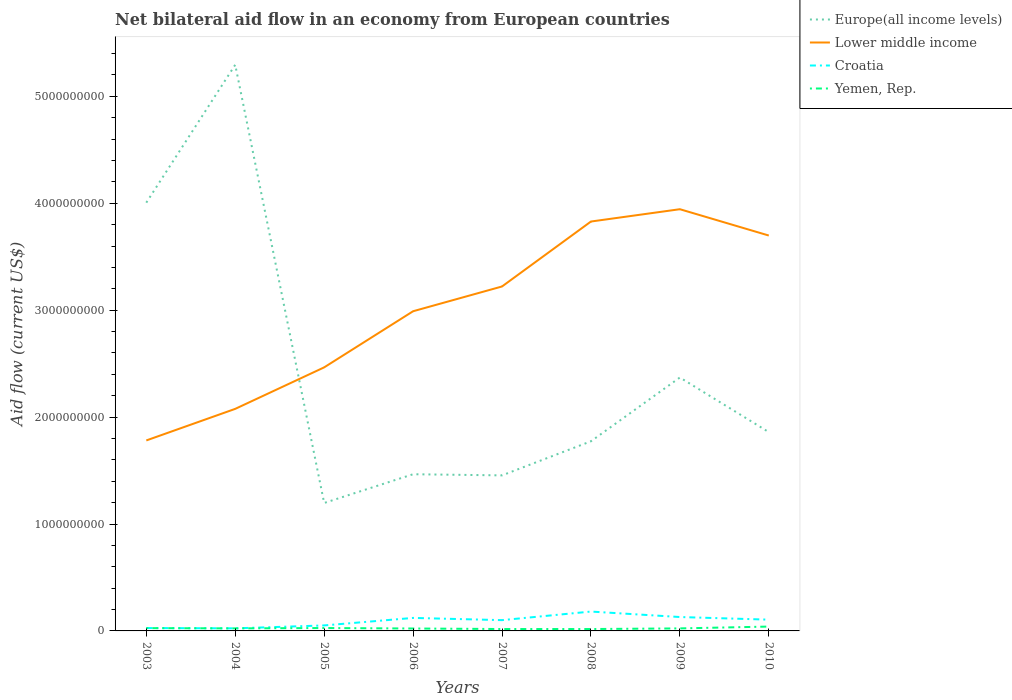Does the line corresponding to Yemen, Rep. intersect with the line corresponding to Croatia?
Your response must be concise. No. Is the number of lines equal to the number of legend labels?
Your response must be concise. Yes. Across all years, what is the maximum net bilateral aid flow in Europe(all income levels)?
Offer a terse response. 1.20e+09. What is the total net bilateral aid flow in Europe(all income levels) in the graph?
Your response must be concise. 3.84e+09. What is the difference between the highest and the second highest net bilateral aid flow in Lower middle income?
Your response must be concise. 2.16e+09. What is the difference between the highest and the lowest net bilateral aid flow in Lower middle income?
Your response must be concise. 4. Is the net bilateral aid flow in Croatia strictly greater than the net bilateral aid flow in Lower middle income over the years?
Ensure brevity in your answer.  Yes. How many lines are there?
Make the answer very short. 4. How many years are there in the graph?
Offer a very short reply. 8. Does the graph contain grids?
Keep it short and to the point. No. How many legend labels are there?
Provide a succinct answer. 4. What is the title of the graph?
Make the answer very short. Net bilateral aid flow in an economy from European countries. What is the label or title of the Y-axis?
Your response must be concise. Aid flow (current US$). What is the Aid flow (current US$) of Europe(all income levels) in 2003?
Your response must be concise. 4.01e+09. What is the Aid flow (current US$) of Lower middle income in 2003?
Provide a succinct answer. 1.78e+09. What is the Aid flow (current US$) in Croatia in 2003?
Your response must be concise. 2.69e+07. What is the Aid flow (current US$) of Yemen, Rep. in 2003?
Your answer should be very brief. 2.62e+07. What is the Aid flow (current US$) in Europe(all income levels) in 2004?
Provide a succinct answer. 5.29e+09. What is the Aid flow (current US$) of Lower middle income in 2004?
Make the answer very short. 2.08e+09. What is the Aid flow (current US$) of Croatia in 2004?
Make the answer very short. 2.41e+07. What is the Aid flow (current US$) of Yemen, Rep. in 2004?
Your answer should be very brief. 2.38e+07. What is the Aid flow (current US$) of Europe(all income levels) in 2005?
Give a very brief answer. 1.20e+09. What is the Aid flow (current US$) in Lower middle income in 2005?
Make the answer very short. 2.46e+09. What is the Aid flow (current US$) of Croatia in 2005?
Provide a succinct answer. 5.14e+07. What is the Aid flow (current US$) of Yemen, Rep. in 2005?
Offer a very short reply. 2.70e+07. What is the Aid flow (current US$) of Europe(all income levels) in 2006?
Provide a succinct answer. 1.47e+09. What is the Aid flow (current US$) of Lower middle income in 2006?
Make the answer very short. 2.99e+09. What is the Aid flow (current US$) of Croatia in 2006?
Ensure brevity in your answer.  1.22e+08. What is the Aid flow (current US$) in Yemen, Rep. in 2006?
Your answer should be very brief. 2.27e+07. What is the Aid flow (current US$) in Europe(all income levels) in 2007?
Ensure brevity in your answer.  1.45e+09. What is the Aid flow (current US$) in Lower middle income in 2007?
Ensure brevity in your answer.  3.22e+09. What is the Aid flow (current US$) in Croatia in 2007?
Your answer should be compact. 1.01e+08. What is the Aid flow (current US$) in Yemen, Rep. in 2007?
Offer a terse response. 1.77e+07. What is the Aid flow (current US$) in Europe(all income levels) in 2008?
Give a very brief answer. 1.77e+09. What is the Aid flow (current US$) in Lower middle income in 2008?
Your answer should be compact. 3.83e+09. What is the Aid flow (current US$) of Croatia in 2008?
Your response must be concise. 1.81e+08. What is the Aid flow (current US$) in Yemen, Rep. in 2008?
Keep it short and to the point. 1.77e+07. What is the Aid flow (current US$) of Europe(all income levels) in 2009?
Keep it short and to the point. 2.37e+09. What is the Aid flow (current US$) of Lower middle income in 2009?
Your answer should be very brief. 3.94e+09. What is the Aid flow (current US$) of Croatia in 2009?
Keep it short and to the point. 1.30e+08. What is the Aid flow (current US$) in Yemen, Rep. in 2009?
Ensure brevity in your answer.  2.36e+07. What is the Aid flow (current US$) in Europe(all income levels) in 2010?
Offer a very short reply. 1.86e+09. What is the Aid flow (current US$) in Lower middle income in 2010?
Your response must be concise. 3.70e+09. What is the Aid flow (current US$) of Croatia in 2010?
Offer a very short reply. 1.05e+08. What is the Aid flow (current US$) of Yemen, Rep. in 2010?
Offer a very short reply. 4.07e+07. Across all years, what is the maximum Aid flow (current US$) of Europe(all income levels)?
Your response must be concise. 5.29e+09. Across all years, what is the maximum Aid flow (current US$) of Lower middle income?
Give a very brief answer. 3.94e+09. Across all years, what is the maximum Aid flow (current US$) in Croatia?
Provide a succinct answer. 1.81e+08. Across all years, what is the maximum Aid flow (current US$) of Yemen, Rep.?
Keep it short and to the point. 4.07e+07. Across all years, what is the minimum Aid flow (current US$) in Europe(all income levels)?
Keep it short and to the point. 1.20e+09. Across all years, what is the minimum Aid flow (current US$) of Lower middle income?
Your answer should be compact. 1.78e+09. Across all years, what is the minimum Aid flow (current US$) of Croatia?
Offer a terse response. 2.41e+07. Across all years, what is the minimum Aid flow (current US$) of Yemen, Rep.?
Your response must be concise. 1.77e+07. What is the total Aid flow (current US$) of Europe(all income levels) in the graph?
Offer a terse response. 1.94e+1. What is the total Aid flow (current US$) in Lower middle income in the graph?
Your answer should be very brief. 2.40e+1. What is the total Aid flow (current US$) in Croatia in the graph?
Your answer should be very brief. 7.41e+08. What is the total Aid flow (current US$) in Yemen, Rep. in the graph?
Provide a short and direct response. 1.99e+08. What is the difference between the Aid flow (current US$) of Europe(all income levels) in 2003 and that in 2004?
Keep it short and to the point. -1.29e+09. What is the difference between the Aid flow (current US$) in Lower middle income in 2003 and that in 2004?
Keep it short and to the point. -2.95e+08. What is the difference between the Aid flow (current US$) of Croatia in 2003 and that in 2004?
Ensure brevity in your answer.  2.78e+06. What is the difference between the Aid flow (current US$) in Yemen, Rep. in 2003 and that in 2004?
Keep it short and to the point. 2.45e+06. What is the difference between the Aid flow (current US$) of Europe(all income levels) in 2003 and that in 2005?
Provide a succinct answer. 2.81e+09. What is the difference between the Aid flow (current US$) in Lower middle income in 2003 and that in 2005?
Offer a terse response. -6.83e+08. What is the difference between the Aid flow (current US$) in Croatia in 2003 and that in 2005?
Ensure brevity in your answer.  -2.45e+07. What is the difference between the Aid flow (current US$) of Yemen, Rep. in 2003 and that in 2005?
Your answer should be very brief. -8.50e+05. What is the difference between the Aid flow (current US$) in Europe(all income levels) in 2003 and that in 2006?
Provide a succinct answer. 2.54e+09. What is the difference between the Aid flow (current US$) in Lower middle income in 2003 and that in 2006?
Your answer should be very brief. -1.21e+09. What is the difference between the Aid flow (current US$) in Croatia in 2003 and that in 2006?
Provide a succinct answer. -9.48e+07. What is the difference between the Aid flow (current US$) in Yemen, Rep. in 2003 and that in 2006?
Ensure brevity in your answer.  3.49e+06. What is the difference between the Aid flow (current US$) of Europe(all income levels) in 2003 and that in 2007?
Offer a terse response. 2.55e+09. What is the difference between the Aid flow (current US$) in Lower middle income in 2003 and that in 2007?
Provide a short and direct response. -1.44e+09. What is the difference between the Aid flow (current US$) in Croatia in 2003 and that in 2007?
Offer a terse response. -7.40e+07. What is the difference between the Aid flow (current US$) in Yemen, Rep. in 2003 and that in 2007?
Provide a short and direct response. 8.46e+06. What is the difference between the Aid flow (current US$) in Europe(all income levels) in 2003 and that in 2008?
Your answer should be very brief. 2.23e+09. What is the difference between the Aid flow (current US$) in Lower middle income in 2003 and that in 2008?
Your answer should be compact. -2.05e+09. What is the difference between the Aid flow (current US$) in Croatia in 2003 and that in 2008?
Keep it short and to the point. -1.54e+08. What is the difference between the Aid flow (current US$) of Yemen, Rep. in 2003 and that in 2008?
Make the answer very short. 8.50e+06. What is the difference between the Aid flow (current US$) of Europe(all income levels) in 2003 and that in 2009?
Your answer should be compact. 1.64e+09. What is the difference between the Aid flow (current US$) in Lower middle income in 2003 and that in 2009?
Offer a terse response. -2.16e+09. What is the difference between the Aid flow (current US$) in Croatia in 2003 and that in 2009?
Your response must be concise. -1.03e+08. What is the difference between the Aid flow (current US$) in Yemen, Rep. in 2003 and that in 2009?
Offer a very short reply. 2.60e+06. What is the difference between the Aid flow (current US$) of Europe(all income levels) in 2003 and that in 2010?
Your response must be concise. 2.15e+09. What is the difference between the Aid flow (current US$) in Lower middle income in 2003 and that in 2010?
Offer a very short reply. -1.92e+09. What is the difference between the Aid flow (current US$) in Croatia in 2003 and that in 2010?
Give a very brief answer. -7.85e+07. What is the difference between the Aid flow (current US$) of Yemen, Rep. in 2003 and that in 2010?
Your answer should be very brief. -1.45e+07. What is the difference between the Aid flow (current US$) in Europe(all income levels) in 2004 and that in 2005?
Provide a short and direct response. 4.10e+09. What is the difference between the Aid flow (current US$) of Lower middle income in 2004 and that in 2005?
Ensure brevity in your answer.  -3.88e+08. What is the difference between the Aid flow (current US$) of Croatia in 2004 and that in 2005?
Give a very brief answer. -2.73e+07. What is the difference between the Aid flow (current US$) in Yemen, Rep. in 2004 and that in 2005?
Offer a terse response. -3.30e+06. What is the difference between the Aid flow (current US$) of Europe(all income levels) in 2004 and that in 2006?
Provide a succinct answer. 3.83e+09. What is the difference between the Aid flow (current US$) of Lower middle income in 2004 and that in 2006?
Your answer should be very brief. -9.13e+08. What is the difference between the Aid flow (current US$) in Croatia in 2004 and that in 2006?
Offer a very short reply. -9.76e+07. What is the difference between the Aid flow (current US$) of Yemen, Rep. in 2004 and that in 2006?
Your answer should be very brief. 1.04e+06. What is the difference between the Aid flow (current US$) of Europe(all income levels) in 2004 and that in 2007?
Offer a terse response. 3.84e+09. What is the difference between the Aid flow (current US$) in Lower middle income in 2004 and that in 2007?
Offer a terse response. -1.14e+09. What is the difference between the Aid flow (current US$) in Croatia in 2004 and that in 2007?
Ensure brevity in your answer.  -7.68e+07. What is the difference between the Aid flow (current US$) in Yemen, Rep. in 2004 and that in 2007?
Offer a terse response. 6.01e+06. What is the difference between the Aid flow (current US$) of Europe(all income levels) in 2004 and that in 2008?
Ensure brevity in your answer.  3.52e+09. What is the difference between the Aid flow (current US$) in Lower middle income in 2004 and that in 2008?
Provide a short and direct response. -1.75e+09. What is the difference between the Aid flow (current US$) of Croatia in 2004 and that in 2008?
Your answer should be very brief. -1.57e+08. What is the difference between the Aid flow (current US$) in Yemen, Rep. in 2004 and that in 2008?
Your answer should be compact. 6.05e+06. What is the difference between the Aid flow (current US$) of Europe(all income levels) in 2004 and that in 2009?
Your answer should be very brief. 2.92e+09. What is the difference between the Aid flow (current US$) in Lower middle income in 2004 and that in 2009?
Ensure brevity in your answer.  -1.87e+09. What is the difference between the Aid flow (current US$) of Croatia in 2004 and that in 2009?
Your response must be concise. -1.06e+08. What is the difference between the Aid flow (current US$) of Yemen, Rep. in 2004 and that in 2009?
Give a very brief answer. 1.50e+05. What is the difference between the Aid flow (current US$) of Europe(all income levels) in 2004 and that in 2010?
Offer a terse response. 3.44e+09. What is the difference between the Aid flow (current US$) in Lower middle income in 2004 and that in 2010?
Your answer should be very brief. -1.62e+09. What is the difference between the Aid flow (current US$) in Croatia in 2004 and that in 2010?
Provide a succinct answer. -8.13e+07. What is the difference between the Aid flow (current US$) of Yemen, Rep. in 2004 and that in 2010?
Offer a terse response. -1.70e+07. What is the difference between the Aid flow (current US$) of Europe(all income levels) in 2005 and that in 2006?
Your answer should be very brief. -2.69e+08. What is the difference between the Aid flow (current US$) of Lower middle income in 2005 and that in 2006?
Your answer should be compact. -5.25e+08. What is the difference between the Aid flow (current US$) in Croatia in 2005 and that in 2006?
Your answer should be compact. -7.03e+07. What is the difference between the Aid flow (current US$) of Yemen, Rep. in 2005 and that in 2006?
Give a very brief answer. 4.34e+06. What is the difference between the Aid flow (current US$) of Europe(all income levels) in 2005 and that in 2007?
Provide a succinct answer. -2.58e+08. What is the difference between the Aid flow (current US$) of Lower middle income in 2005 and that in 2007?
Offer a terse response. -7.57e+08. What is the difference between the Aid flow (current US$) in Croatia in 2005 and that in 2007?
Your answer should be compact. -4.95e+07. What is the difference between the Aid flow (current US$) of Yemen, Rep. in 2005 and that in 2007?
Your answer should be compact. 9.31e+06. What is the difference between the Aid flow (current US$) in Europe(all income levels) in 2005 and that in 2008?
Your answer should be compact. -5.77e+08. What is the difference between the Aid flow (current US$) of Lower middle income in 2005 and that in 2008?
Make the answer very short. -1.36e+09. What is the difference between the Aid flow (current US$) of Croatia in 2005 and that in 2008?
Offer a terse response. -1.30e+08. What is the difference between the Aid flow (current US$) of Yemen, Rep. in 2005 and that in 2008?
Your answer should be very brief. 9.35e+06. What is the difference between the Aid flow (current US$) in Europe(all income levels) in 2005 and that in 2009?
Your answer should be very brief. -1.17e+09. What is the difference between the Aid flow (current US$) in Lower middle income in 2005 and that in 2009?
Keep it short and to the point. -1.48e+09. What is the difference between the Aid flow (current US$) in Croatia in 2005 and that in 2009?
Offer a terse response. -7.85e+07. What is the difference between the Aid flow (current US$) of Yemen, Rep. in 2005 and that in 2009?
Provide a short and direct response. 3.45e+06. What is the difference between the Aid flow (current US$) of Europe(all income levels) in 2005 and that in 2010?
Your response must be concise. -6.63e+08. What is the difference between the Aid flow (current US$) in Lower middle income in 2005 and that in 2010?
Your answer should be very brief. -1.23e+09. What is the difference between the Aid flow (current US$) in Croatia in 2005 and that in 2010?
Provide a succinct answer. -5.40e+07. What is the difference between the Aid flow (current US$) of Yemen, Rep. in 2005 and that in 2010?
Keep it short and to the point. -1.37e+07. What is the difference between the Aid flow (current US$) of Europe(all income levels) in 2006 and that in 2007?
Give a very brief answer. 1.07e+07. What is the difference between the Aid flow (current US$) in Lower middle income in 2006 and that in 2007?
Make the answer very short. -2.32e+08. What is the difference between the Aid flow (current US$) in Croatia in 2006 and that in 2007?
Your response must be concise. 2.08e+07. What is the difference between the Aid flow (current US$) of Yemen, Rep. in 2006 and that in 2007?
Keep it short and to the point. 4.97e+06. What is the difference between the Aid flow (current US$) of Europe(all income levels) in 2006 and that in 2008?
Your response must be concise. -3.08e+08. What is the difference between the Aid flow (current US$) in Lower middle income in 2006 and that in 2008?
Keep it short and to the point. -8.39e+08. What is the difference between the Aid flow (current US$) of Croatia in 2006 and that in 2008?
Provide a succinct answer. -5.94e+07. What is the difference between the Aid flow (current US$) in Yemen, Rep. in 2006 and that in 2008?
Ensure brevity in your answer.  5.01e+06. What is the difference between the Aid flow (current US$) in Europe(all income levels) in 2006 and that in 2009?
Offer a terse response. -9.05e+08. What is the difference between the Aid flow (current US$) in Lower middle income in 2006 and that in 2009?
Ensure brevity in your answer.  -9.54e+08. What is the difference between the Aid flow (current US$) in Croatia in 2006 and that in 2009?
Your answer should be compact. -8.24e+06. What is the difference between the Aid flow (current US$) of Yemen, Rep. in 2006 and that in 2009?
Your answer should be compact. -8.90e+05. What is the difference between the Aid flow (current US$) in Europe(all income levels) in 2006 and that in 2010?
Provide a short and direct response. -3.94e+08. What is the difference between the Aid flow (current US$) in Lower middle income in 2006 and that in 2010?
Your response must be concise. -7.08e+08. What is the difference between the Aid flow (current US$) in Croatia in 2006 and that in 2010?
Offer a very short reply. 1.63e+07. What is the difference between the Aid flow (current US$) in Yemen, Rep. in 2006 and that in 2010?
Give a very brief answer. -1.80e+07. What is the difference between the Aid flow (current US$) in Europe(all income levels) in 2007 and that in 2008?
Ensure brevity in your answer.  -3.19e+08. What is the difference between the Aid flow (current US$) in Lower middle income in 2007 and that in 2008?
Make the answer very short. -6.07e+08. What is the difference between the Aid flow (current US$) in Croatia in 2007 and that in 2008?
Keep it short and to the point. -8.03e+07. What is the difference between the Aid flow (current US$) of Europe(all income levels) in 2007 and that in 2009?
Offer a very short reply. -9.15e+08. What is the difference between the Aid flow (current US$) in Lower middle income in 2007 and that in 2009?
Your answer should be compact. -7.23e+08. What is the difference between the Aid flow (current US$) in Croatia in 2007 and that in 2009?
Your answer should be compact. -2.91e+07. What is the difference between the Aid flow (current US$) in Yemen, Rep. in 2007 and that in 2009?
Offer a very short reply. -5.86e+06. What is the difference between the Aid flow (current US$) of Europe(all income levels) in 2007 and that in 2010?
Provide a short and direct response. -4.05e+08. What is the difference between the Aid flow (current US$) in Lower middle income in 2007 and that in 2010?
Keep it short and to the point. -4.76e+08. What is the difference between the Aid flow (current US$) in Croatia in 2007 and that in 2010?
Your answer should be compact. -4.52e+06. What is the difference between the Aid flow (current US$) of Yemen, Rep. in 2007 and that in 2010?
Your answer should be very brief. -2.30e+07. What is the difference between the Aid flow (current US$) in Europe(all income levels) in 2008 and that in 2009?
Provide a succinct answer. -5.96e+08. What is the difference between the Aid flow (current US$) in Lower middle income in 2008 and that in 2009?
Offer a terse response. -1.15e+08. What is the difference between the Aid flow (current US$) in Croatia in 2008 and that in 2009?
Make the answer very short. 5.12e+07. What is the difference between the Aid flow (current US$) of Yemen, Rep. in 2008 and that in 2009?
Offer a very short reply. -5.90e+06. What is the difference between the Aid flow (current US$) of Europe(all income levels) in 2008 and that in 2010?
Keep it short and to the point. -8.57e+07. What is the difference between the Aid flow (current US$) of Lower middle income in 2008 and that in 2010?
Your response must be concise. 1.31e+08. What is the difference between the Aid flow (current US$) in Croatia in 2008 and that in 2010?
Give a very brief answer. 7.57e+07. What is the difference between the Aid flow (current US$) of Yemen, Rep. in 2008 and that in 2010?
Your answer should be compact. -2.30e+07. What is the difference between the Aid flow (current US$) of Europe(all income levels) in 2009 and that in 2010?
Provide a short and direct response. 5.11e+08. What is the difference between the Aid flow (current US$) in Lower middle income in 2009 and that in 2010?
Ensure brevity in your answer.  2.46e+08. What is the difference between the Aid flow (current US$) of Croatia in 2009 and that in 2010?
Provide a succinct answer. 2.46e+07. What is the difference between the Aid flow (current US$) in Yemen, Rep. in 2009 and that in 2010?
Provide a short and direct response. -1.71e+07. What is the difference between the Aid flow (current US$) of Europe(all income levels) in 2003 and the Aid flow (current US$) of Lower middle income in 2004?
Your answer should be very brief. 1.93e+09. What is the difference between the Aid flow (current US$) in Europe(all income levels) in 2003 and the Aid flow (current US$) in Croatia in 2004?
Your answer should be compact. 3.98e+09. What is the difference between the Aid flow (current US$) of Europe(all income levels) in 2003 and the Aid flow (current US$) of Yemen, Rep. in 2004?
Offer a terse response. 3.98e+09. What is the difference between the Aid flow (current US$) of Lower middle income in 2003 and the Aid flow (current US$) of Croatia in 2004?
Make the answer very short. 1.76e+09. What is the difference between the Aid flow (current US$) in Lower middle income in 2003 and the Aid flow (current US$) in Yemen, Rep. in 2004?
Give a very brief answer. 1.76e+09. What is the difference between the Aid flow (current US$) of Croatia in 2003 and the Aid flow (current US$) of Yemen, Rep. in 2004?
Make the answer very short. 3.14e+06. What is the difference between the Aid flow (current US$) in Europe(all income levels) in 2003 and the Aid flow (current US$) in Lower middle income in 2005?
Provide a succinct answer. 1.54e+09. What is the difference between the Aid flow (current US$) in Europe(all income levels) in 2003 and the Aid flow (current US$) in Croatia in 2005?
Provide a succinct answer. 3.95e+09. What is the difference between the Aid flow (current US$) of Europe(all income levels) in 2003 and the Aid flow (current US$) of Yemen, Rep. in 2005?
Offer a very short reply. 3.98e+09. What is the difference between the Aid flow (current US$) of Lower middle income in 2003 and the Aid flow (current US$) of Croatia in 2005?
Offer a very short reply. 1.73e+09. What is the difference between the Aid flow (current US$) of Lower middle income in 2003 and the Aid flow (current US$) of Yemen, Rep. in 2005?
Your answer should be compact. 1.75e+09. What is the difference between the Aid flow (current US$) of Europe(all income levels) in 2003 and the Aid flow (current US$) of Lower middle income in 2006?
Provide a short and direct response. 1.02e+09. What is the difference between the Aid flow (current US$) in Europe(all income levels) in 2003 and the Aid flow (current US$) in Croatia in 2006?
Ensure brevity in your answer.  3.88e+09. What is the difference between the Aid flow (current US$) of Europe(all income levels) in 2003 and the Aid flow (current US$) of Yemen, Rep. in 2006?
Give a very brief answer. 3.98e+09. What is the difference between the Aid flow (current US$) in Lower middle income in 2003 and the Aid flow (current US$) in Croatia in 2006?
Provide a succinct answer. 1.66e+09. What is the difference between the Aid flow (current US$) in Lower middle income in 2003 and the Aid flow (current US$) in Yemen, Rep. in 2006?
Offer a terse response. 1.76e+09. What is the difference between the Aid flow (current US$) of Croatia in 2003 and the Aid flow (current US$) of Yemen, Rep. in 2006?
Make the answer very short. 4.18e+06. What is the difference between the Aid flow (current US$) of Europe(all income levels) in 2003 and the Aid flow (current US$) of Lower middle income in 2007?
Your answer should be very brief. 7.84e+08. What is the difference between the Aid flow (current US$) in Europe(all income levels) in 2003 and the Aid flow (current US$) in Croatia in 2007?
Your answer should be very brief. 3.90e+09. What is the difference between the Aid flow (current US$) in Europe(all income levels) in 2003 and the Aid flow (current US$) in Yemen, Rep. in 2007?
Keep it short and to the point. 3.99e+09. What is the difference between the Aid flow (current US$) in Lower middle income in 2003 and the Aid flow (current US$) in Croatia in 2007?
Offer a very short reply. 1.68e+09. What is the difference between the Aid flow (current US$) of Lower middle income in 2003 and the Aid flow (current US$) of Yemen, Rep. in 2007?
Provide a short and direct response. 1.76e+09. What is the difference between the Aid flow (current US$) of Croatia in 2003 and the Aid flow (current US$) of Yemen, Rep. in 2007?
Provide a succinct answer. 9.15e+06. What is the difference between the Aid flow (current US$) of Europe(all income levels) in 2003 and the Aid flow (current US$) of Lower middle income in 2008?
Your response must be concise. 1.76e+08. What is the difference between the Aid flow (current US$) in Europe(all income levels) in 2003 and the Aid flow (current US$) in Croatia in 2008?
Your response must be concise. 3.82e+09. What is the difference between the Aid flow (current US$) in Europe(all income levels) in 2003 and the Aid flow (current US$) in Yemen, Rep. in 2008?
Your answer should be very brief. 3.99e+09. What is the difference between the Aid flow (current US$) of Lower middle income in 2003 and the Aid flow (current US$) of Croatia in 2008?
Your response must be concise. 1.60e+09. What is the difference between the Aid flow (current US$) in Lower middle income in 2003 and the Aid flow (current US$) in Yemen, Rep. in 2008?
Give a very brief answer. 1.76e+09. What is the difference between the Aid flow (current US$) of Croatia in 2003 and the Aid flow (current US$) of Yemen, Rep. in 2008?
Your answer should be compact. 9.19e+06. What is the difference between the Aid flow (current US$) of Europe(all income levels) in 2003 and the Aid flow (current US$) of Lower middle income in 2009?
Your answer should be very brief. 6.12e+07. What is the difference between the Aid flow (current US$) in Europe(all income levels) in 2003 and the Aid flow (current US$) in Croatia in 2009?
Keep it short and to the point. 3.88e+09. What is the difference between the Aid flow (current US$) in Europe(all income levels) in 2003 and the Aid flow (current US$) in Yemen, Rep. in 2009?
Ensure brevity in your answer.  3.98e+09. What is the difference between the Aid flow (current US$) in Lower middle income in 2003 and the Aid flow (current US$) in Croatia in 2009?
Ensure brevity in your answer.  1.65e+09. What is the difference between the Aid flow (current US$) in Lower middle income in 2003 and the Aid flow (current US$) in Yemen, Rep. in 2009?
Make the answer very short. 1.76e+09. What is the difference between the Aid flow (current US$) in Croatia in 2003 and the Aid flow (current US$) in Yemen, Rep. in 2009?
Make the answer very short. 3.29e+06. What is the difference between the Aid flow (current US$) of Europe(all income levels) in 2003 and the Aid flow (current US$) of Lower middle income in 2010?
Provide a succinct answer. 3.07e+08. What is the difference between the Aid flow (current US$) in Europe(all income levels) in 2003 and the Aid flow (current US$) in Croatia in 2010?
Your answer should be very brief. 3.90e+09. What is the difference between the Aid flow (current US$) of Europe(all income levels) in 2003 and the Aid flow (current US$) of Yemen, Rep. in 2010?
Keep it short and to the point. 3.96e+09. What is the difference between the Aid flow (current US$) of Lower middle income in 2003 and the Aid flow (current US$) of Croatia in 2010?
Your answer should be compact. 1.68e+09. What is the difference between the Aid flow (current US$) in Lower middle income in 2003 and the Aid flow (current US$) in Yemen, Rep. in 2010?
Give a very brief answer. 1.74e+09. What is the difference between the Aid flow (current US$) in Croatia in 2003 and the Aid flow (current US$) in Yemen, Rep. in 2010?
Offer a very short reply. -1.38e+07. What is the difference between the Aid flow (current US$) in Europe(all income levels) in 2004 and the Aid flow (current US$) in Lower middle income in 2005?
Give a very brief answer. 2.83e+09. What is the difference between the Aid flow (current US$) in Europe(all income levels) in 2004 and the Aid flow (current US$) in Croatia in 2005?
Keep it short and to the point. 5.24e+09. What is the difference between the Aid flow (current US$) of Europe(all income levels) in 2004 and the Aid flow (current US$) of Yemen, Rep. in 2005?
Your response must be concise. 5.27e+09. What is the difference between the Aid flow (current US$) in Lower middle income in 2004 and the Aid flow (current US$) in Croatia in 2005?
Provide a short and direct response. 2.03e+09. What is the difference between the Aid flow (current US$) in Lower middle income in 2004 and the Aid flow (current US$) in Yemen, Rep. in 2005?
Keep it short and to the point. 2.05e+09. What is the difference between the Aid flow (current US$) in Croatia in 2004 and the Aid flow (current US$) in Yemen, Rep. in 2005?
Your answer should be compact. -2.94e+06. What is the difference between the Aid flow (current US$) in Europe(all income levels) in 2004 and the Aid flow (current US$) in Lower middle income in 2006?
Your answer should be very brief. 2.31e+09. What is the difference between the Aid flow (current US$) of Europe(all income levels) in 2004 and the Aid flow (current US$) of Croatia in 2006?
Offer a very short reply. 5.17e+09. What is the difference between the Aid flow (current US$) of Europe(all income levels) in 2004 and the Aid flow (current US$) of Yemen, Rep. in 2006?
Keep it short and to the point. 5.27e+09. What is the difference between the Aid flow (current US$) in Lower middle income in 2004 and the Aid flow (current US$) in Croatia in 2006?
Make the answer very short. 1.96e+09. What is the difference between the Aid flow (current US$) of Lower middle income in 2004 and the Aid flow (current US$) of Yemen, Rep. in 2006?
Your response must be concise. 2.05e+09. What is the difference between the Aid flow (current US$) of Croatia in 2004 and the Aid flow (current US$) of Yemen, Rep. in 2006?
Ensure brevity in your answer.  1.40e+06. What is the difference between the Aid flow (current US$) in Europe(all income levels) in 2004 and the Aid flow (current US$) in Lower middle income in 2007?
Your answer should be very brief. 2.07e+09. What is the difference between the Aid flow (current US$) in Europe(all income levels) in 2004 and the Aid flow (current US$) in Croatia in 2007?
Offer a terse response. 5.19e+09. What is the difference between the Aid flow (current US$) in Europe(all income levels) in 2004 and the Aid flow (current US$) in Yemen, Rep. in 2007?
Offer a very short reply. 5.28e+09. What is the difference between the Aid flow (current US$) of Lower middle income in 2004 and the Aid flow (current US$) of Croatia in 2007?
Your answer should be very brief. 1.98e+09. What is the difference between the Aid flow (current US$) of Lower middle income in 2004 and the Aid flow (current US$) of Yemen, Rep. in 2007?
Your response must be concise. 2.06e+09. What is the difference between the Aid flow (current US$) in Croatia in 2004 and the Aid flow (current US$) in Yemen, Rep. in 2007?
Provide a short and direct response. 6.37e+06. What is the difference between the Aid flow (current US$) in Europe(all income levels) in 2004 and the Aid flow (current US$) in Lower middle income in 2008?
Offer a terse response. 1.47e+09. What is the difference between the Aid flow (current US$) of Europe(all income levels) in 2004 and the Aid flow (current US$) of Croatia in 2008?
Give a very brief answer. 5.11e+09. What is the difference between the Aid flow (current US$) of Europe(all income levels) in 2004 and the Aid flow (current US$) of Yemen, Rep. in 2008?
Your answer should be compact. 5.28e+09. What is the difference between the Aid flow (current US$) in Lower middle income in 2004 and the Aid flow (current US$) in Croatia in 2008?
Ensure brevity in your answer.  1.90e+09. What is the difference between the Aid flow (current US$) of Lower middle income in 2004 and the Aid flow (current US$) of Yemen, Rep. in 2008?
Offer a terse response. 2.06e+09. What is the difference between the Aid flow (current US$) in Croatia in 2004 and the Aid flow (current US$) in Yemen, Rep. in 2008?
Your answer should be compact. 6.41e+06. What is the difference between the Aid flow (current US$) of Europe(all income levels) in 2004 and the Aid flow (current US$) of Lower middle income in 2009?
Your answer should be very brief. 1.35e+09. What is the difference between the Aid flow (current US$) of Europe(all income levels) in 2004 and the Aid flow (current US$) of Croatia in 2009?
Provide a short and direct response. 5.17e+09. What is the difference between the Aid flow (current US$) of Europe(all income levels) in 2004 and the Aid flow (current US$) of Yemen, Rep. in 2009?
Your answer should be very brief. 5.27e+09. What is the difference between the Aid flow (current US$) of Lower middle income in 2004 and the Aid flow (current US$) of Croatia in 2009?
Your response must be concise. 1.95e+09. What is the difference between the Aid flow (current US$) of Lower middle income in 2004 and the Aid flow (current US$) of Yemen, Rep. in 2009?
Offer a very short reply. 2.05e+09. What is the difference between the Aid flow (current US$) of Croatia in 2004 and the Aid flow (current US$) of Yemen, Rep. in 2009?
Your response must be concise. 5.10e+05. What is the difference between the Aid flow (current US$) in Europe(all income levels) in 2004 and the Aid flow (current US$) in Lower middle income in 2010?
Provide a short and direct response. 1.60e+09. What is the difference between the Aid flow (current US$) in Europe(all income levels) in 2004 and the Aid flow (current US$) in Croatia in 2010?
Give a very brief answer. 5.19e+09. What is the difference between the Aid flow (current US$) in Europe(all income levels) in 2004 and the Aid flow (current US$) in Yemen, Rep. in 2010?
Your answer should be very brief. 5.25e+09. What is the difference between the Aid flow (current US$) in Lower middle income in 2004 and the Aid flow (current US$) in Croatia in 2010?
Keep it short and to the point. 1.97e+09. What is the difference between the Aid flow (current US$) of Lower middle income in 2004 and the Aid flow (current US$) of Yemen, Rep. in 2010?
Give a very brief answer. 2.04e+09. What is the difference between the Aid flow (current US$) of Croatia in 2004 and the Aid flow (current US$) of Yemen, Rep. in 2010?
Offer a very short reply. -1.66e+07. What is the difference between the Aid flow (current US$) of Europe(all income levels) in 2005 and the Aid flow (current US$) of Lower middle income in 2006?
Your answer should be very brief. -1.79e+09. What is the difference between the Aid flow (current US$) of Europe(all income levels) in 2005 and the Aid flow (current US$) of Croatia in 2006?
Ensure brevity in your answer.  1.07e+09. What is the difference between the Aid flow (current US$) in Europe(all income levels) in 2005 and the Aid flow (current US$) in Yemen, Rep. in 2006?
Your response must be concise. 1.17e+09. What is the difference between the Aid flow (current US$) of Lower middle income in 2005 and the Aid flow (current US$) of Croatia in 2006?
Your answer should be very brief. 2.34e+09. What is the difference between the Aid flow (current US$) in Lower middle income in 2005 and the Aid flow (current US$) in Yemen, Rep. in 2006?
Make the answer very short. 2.44e+09. What is the difference between the Aid flow (current US$) of Croatia in 2005 and the Aid flow (current US$) of Yemen, Rep. in 2006?
Your response must be concise. 2.87e+07. What is the difference between the Aid flow (current US$) in Europe(all income levels) in 2005 and the Aid flow (current US$) in Lower middle income in 2007?
Keep it short and to the point. -2.02e+09. What is the difference between the Aid flow (current US$) in Europe(all income levels) in 2005 and the Aid flow (current US$) in Croatia in 2007?
Your answer should be compact. 1.10e+09. What is the difference between the Aid flow (current US$) in Europe(all income levels) in 2005 and the Aid flow (current US$) in Yemen, Rep. in 2007?
Your answer should be compact. 1.18e+09. What is the difference between the Aid flow (current US$) of Lower middle income in 2005 and the Aid flow (current US$) of Croatia in 2007?
Your response must be concise. 2.36e+09. What is the difference between the Aid flow (current US$) in Lower middle income in 2005 and the Aid flow (current US$) in Yemen, Rep. in 2007?
Keep it short and to the point. 2.45e+09. What is the difference between the Aid flow (current US$) in Croatia in 2005 and the Aid flow (current US$) in Yemen, Rep. in 2007?
Keep it short and to the point. 3.37e+07. What is the difference between the Aid flow (current US$) of Europe(all income levels) in 2005 and the Aid flow (current US$) of Lower middle income in 2008?
Ensure brevity in your answer.  -2.63e+09. What is the difference between the Aid flow (current US$) of Europe(all income levels) in 2005 and the Aid flow (current US$) of Croatia in 2008?
Provide a short and direct response. 1.02e+09. What is the difference between the Aid flow (current US$) in Europe(all income levels) in 2005 and the Aid flow (current US$) in Yemen, Rep. in 2008?
Your answer should be very brief. 1.18e+09. What is the difference between the Aid flow (current US$) of Lower middle income in 2005 and the Aid flow (current US$) of Croatia in 2008?
Provide a short and direct response. 2.28e+09. What is the difference between the Aid flow (current US$) of Lower middle income in 2005 and the Aid flow (current US$) of Yemen, Rep. in 2008?
Offer a terse response. 2.45e+09. What is the difference between the Aid flow (current US$) in Croatia in 2005 and the Aid flow (current US$) in Yemen, Rep. in 2008?
Your response must be concise. 3.37e+07. What is the difference between the Aid flow (current US$) in Europe(all income levels) in 2005 and the Aid flow (current US$) in Lower middle income in 2009?
Give a very brief answer. -2.75e+09. What is the difference between the Aid flow (current US$) in Europe(all income levels) in 2005 and the Aid flow (current US$) in Croatia in 2009?
Offer a very short reply. 1.07e+09. What is the difference between the Aid flow (current US$) in Europe(all income levels) in 2005 and the Aid flow (current US$) in Yemen, Rep. in 2009?
Give a very brief answer. 1.17e+09. What is the difference between the Aid flow (current US$) of Lower middle income in 2005 and the Aid flow (current US$) of Croatia in 2009?
Ensure brevity in your answer.  2.33e+09. What is the difference between the Aid flow (current US$) of Lower middle income in 2005 and the Aid flow (current US$) of Yemen, Rep. in 2009?
Your answer should be compact. 2.44e+09. What is the difference between the Aid flow (current US$) of Croatia in 2005 and the Aid flow (current US$) of Yemen, Rep. in 2009?
Your response must be concise. 2.78e+07. What is the difference between the Aid flow (current US$) in Europe(all income levels) in 2005 and the Aid flow (current US$) in Lower middle income in 2010?
Your answer should be very brief. -2.50e+09. What is the difference between the Aid flow (current US$) in Europe(all income levels) in 2005 and the Aid flow (current US$) in Croatia in 2010?
Provide a succinct answer. 1.09e+09. What is the difference between the Aid flow (current US$) in Europe(all income levels) in 2005 and the Aid flow (current US$) in Yemen, Rep. in 2010?
Provide a succinct answer. 1.16e+09. What is the difference between the Aid flow (current US$) in Lower middle income in 2005 and the Aid flow (current US$) in Croatia in 2010?
Your response must be concise. 2.36e+09. What is the difference between the Aid flow (current US$) of Lower middle income in 2005 and the Aid flow (current US$) of Yemen, Rep. in 2010?
Offer a terse response. 2.42e+09. What is the difference between the Aid flow (current US$) in Croatia in 2005 and the Aid flow (current US$) in Yemen, Rep. in 2010?
Provide a short and direct response. 1.07e+07. What is the difference between the Aid flow (current US$) of Europe(all income levels) in 2006 and the Aid flow (current US$) of Lower middle income in 2007?
Make the answer very short. -1.76e+09. What is the difference between the Aid flow (current US$) of Europe(all income levels) in 2006 and the Aid flow (current US$) of Croatia in 2007?
Your response must be concise. 1.36e+09. What is the difference between the Aid flow (current US$) of Europe(all income levels) in 2006 and the Aid flow (current US$) of Yemen, Rep. in 2007?
Offer a very short reply. 1.45e+09. What is the difference between the Aid flow (current US$) of Lower middle income in 2006 and the Aid flow (current US$) of Croatia in 2007?
Offer a very short reply. 2.89e+09. What is the difference between the Aid flow (current US$) of Lower middle income in 2006 and the Aid flow (current US$) of Yemen, Rep. in 2007?
Your answer should be compact. 2.97e+09. What is the difference between the Aid flow (current US$) of Croatia in 2006 and the Aid flow (current US$) of Yemen, Rep. in 2007?
Keep it short and to the point. 1.04e+08. What is the difference between the Aid flow (current US$) of Europe(all income levels) in 2006 and the Aid flow (current US$) of Lower middle income in 2008?
Provide a succinct answer. -2.36e+09. What is the difference between the Aid flow (current US$) in Europe(all income levels) in 2006 and the Aid flow (current US$) in Croatia in 2008?
Ensure brevity in your answer.  1.28e+09. What is the difference between the Aid flow (current US$) in Europe(all income levels) in 2006 and the Aid flow (current US$) in Yemen, Rep. in 2008?
Offer a terse response. 1.45e+09. What is the difference between the Aid flow (current US$) in Lower middle income in 2006 and the Aid flow (current US$) in Croatia in 2008?
Offer a terse response. 2.81e+09. What is the difference between the Aid flow (current US$) of Lower middle income in 2006 and the Aid flow (current US$) of Yemen, Rep. in 2008?
Make the answer very short. 2.97e+09. What is the difference between the Aid flow (current US$) in Croatia in 2006 and the Aid flow (current US$) in Yemen, Rep. in 2008?
Ensure brevity in your answer.  1.04e+08. What is the difference between the Aid flow (current US$) of Europe(all income levels) in 2006 and the Aid flow (current US$) of Lower middle income in 2009?
Offer a very short reply. -2.48e+09. What is the difference between the Aid flow (current US$) in Europe(all income levels) in 2006 and the Aid flow (current US$) in Croatia in 2009?
Your answer should be compact. 1.34e+09. What is the difference between the Aid flow (current US$) of Europe(all income levels) in 2006 and the Aid flow (current US$) of Yemen, Rep. in 2009?
Your answer should be very brief. 1.44e+09. What is the difference between the Aid flow (current US$) of Lower middle income in 2006 and the Aid flow (current US$) of Croatia in 2009?
Provide a succinct answer. 2.86e+09. What is the difference between the Aid flow (current US$) of Lower middle income in 2006 and the Aid flow (current US$) of Yemen, Rep. in 2009?
Offer a terse response. 2.97e+09. What is the difference between the Aid flow (current US$) in Croatia in 2006 and the Aid flow (current US$) in Yemen, Rep. in 2009?
Offer a very short reply. 9.81e+07. What is the difference between the Aid flow (current US$) in Europe(all income levels) in 2006 and the Aid flow (current US$) in Lower middle income in 2010?
Your answer should be very brief. -2.23e+09. What is the difference between the Aid flow (current US$) in Europe(all income levels) in 2006 and the Aid flow (current US$) in Croatia in 2010?
Provide a short and direct response. 1.36e+09. What is the difference between the Aid flow (current US$) in Europe(all income levels) in 2006 and the Aid flow (current US$) in Yemen, Rep. in 2010?
Provide a short and direct response. 1.42e+09. What is the difference between the Aid flow (current US$) of Lower middle income in 2006 and the Aid flow (current US$) of Croatia in 2010?
Your answer should be very brief. 2.88e+09. What is the difference between the Aid flow (current US$) in Lower middle income in 2006 and the Aid flow (current US$) in Yemen, Rep. in 2010?
Make the answer very short. 2.95e+09. What is the difference between the Aid flow (current US$) of Croatia in 2006 and the Aid flow (current US$) of Yemen, Rep. in 2010?
Provide a succinct answer. 8.10e+07. What is the difference between the Aid flow (current US$) of Europe(all income levels) in 2007 and the Aid flow (current US$) of Lower middle income in 2008?
Offer a very short reply. -2.37e+09. What is the difference between the Aid flow (current US$) in Europe(all income levels) in 2007 and the Aid flow (current US$) in Croatia in 2008?
Make the answer very short. 1.27e+09. What is the difference between the Aid flow (current US$) in Europe(all income levels) in 2007 and the Aid flow (current US$) in Yemen, Rep. in 2008?
Offer a terse response. 1.44e+09. What is the difference between the Aid flow (current US$) in Lower middle income in 2007 and the Aid flow (current US$) in Croatia in 2008?
Your response must be concise. 3.04e+09. What is the difference between the Aid flow (current US$) of Lower middle income in 2007 and the Aid flow (current US$) of Yemen, Rep. in 2008?
Provide a succinct answer. 3.20e+09. What is the difference between the Aid flow (current US$) in Croatia in 2007 and the Aid flow (current US$) in Yemen, Rep. in 2008?
Offer a very short reply. 8.32e+07. What is the difference between the Aid flow (current US$) of Europe(all income levels) in 2007 and the Aid flow (current US$) of Lower middle income in 2009?
Keep it short and to the point. -2.49e+09. What is the difference between the Aid flow (current US$) in Europe(all income levels) in 2007 and the Aid flow (current US$) in Croatia in 2009?
Keep it short and to the point. 1.32e+09. What is the difference between the Aid flow (current US$) of Europe(all income levels) in 2007 and the Aid flow (current US$) of Yemen, Rep. in 2009?
Give a very brief answer. 1.43e+09. What is the difference between the Aid flow (current US$) of Lower middle income in 2007 and the Aid flow (current US$) of Croatia in 2009?
Keep it short and to the point. 3.09e+09. What is the difference between the Aid flow (current US$) in Lower middle income in 2007 and the Aid flow (current US$) in Yemen, Rep. in 2009?
Give a very brief answer. 3.20e+09. What is the difference between the Aid flow (current US$) of Croatia in 2007 and the Aid flow (current US$) of Yemen, Rep. in 2009?
Provide a short and direct response. 7.73e+07. What is the difference between the Aid flow (current US$) in Europe(all income levels) in 2007 and the Aid flow (current US$) in Lower middle income in 2010?
Ensure brevity in your answer.  -2.24e+09. What is the difference between the Aid flow (current US$) of Europe(all income levels) in 2007 and the Aid flow (current US$) of Croatia in 2010?
Make the answer very short. 1.35e+09. What is the difference between the Aid flow (current US$) in Europe(all income levels) in 2007 and the Aid flow (current US$) in Yemen, Rep. in 2010?
Offer a very short reply. 1.41e+09. What is the difference between the Aid flow (current US$) of Lower middle income in 2007 and the Aid flow (current US$) of Croatia in 2010?
Your response must be concise. 3.12e+09. What is the difference between the Aid flow (current US$) in Lower middle income in 2007 and the Aid flow (current US$) in Yemen, Rep. in 2010?
Your response must be concise. 3.18e+09. What is the difference between the Aid flow (current US$) in Croatia in 2007 and the Aid flow (current US$) in Yemen, Rep. in 2010?
Your answer should be compact. 6.01e+07. What is the difference between the Aid flow (current US$) in Europe(all income levels) in 2008 and the Aid flow (current US$) in Lower middle income in 2009?
Make the answer very short. -2.17e+09. What is the difference between the Aid flow (current US$) in Europe(all income levels) in 2008 and the Aid flow (current US$) in Croatia in 2009?
Your answer should be very brief. 1.64e+09. What is the difference between the Aid flow (current US$) in Europe(all income levels) in 2008 and the Aid flow (current US$) in Yemen, Rep. in 2009?
Your response must be concise. 1.75e+09. What is the difference between the Aid flow (current US$) in Lower middle income in 2008 and the Aid flow (current US$) in Croatia in 2009?
Your answer should be very brief. 3.70e+09. What is the difference between the Aid flow (current US$) in Lower middle income in 2008 and the Aid flow (current US$) in Yemen, Rep. in 2009?
Provide a short and direct response. 3.81e+09. What is the difference between the Aid flow (current US$) of Croatia in 2008 and the Aid flow (current US$) of Yemen, Rep. in 2009?
Your answer should be compact. 1.58e+08. What is the difference between the Aid flow (current US$) of Europe(all income levels) in 2008 and the Aid flow (current US$) of Lower middle income in 2010?
Your response must be concise. -1.92e+09. What is the difference between the Aid flow (current US$) in Europe(all income levels) in 2008 and the Aid flow (current US$) in Croatia in 2010?
Your response must be concise. 1.67e+09. What is the difference between the Aid flow (current US$) of Europe(all income levels) in 2008 and the Aid flow (current US$) of Yemen, Rep. in 2010?
Provide a short and direct response. 1.73e+09. What is the difference between the Aid flow (current US$) of Lower middle income in 2008 and the Aid flow (current US$) of Croatia in 2010?
Ensure brevity in your answer.  3.72e+09. What is the difference between the Aid flow (current US$) in Lower middle income in 2008 and the Aid flow (current US$) in Yemen, Rep. in 2010?
Your answer should be very brief. 3.79e+09. What is the difference between the Aid flow (current US$) of Croatia in 2008 and the Aid flow (current US$) of Yemen, Rep. in 2010?
Give a very brief answer. 1.40e+08. What is the difference between the Aid flow (current US$) in Europe(all income levels) in 2009 and the Aid flow (current US$) in Lower middle income in 2010?
Your answer should be compact. -1.33e+09. What is the difference between the Aid flow (current US$) in Europe(all income levels) in 2009 and the Aid flow (current US$) in Croatia in 2010?
Ensure brevity in your answer.  2.26e+09. What is the difference between the Aid flow (current US$) in Europe(all income levels) in 2009 and the Aid flow (current US$) in Yemen, Rep. in 2010?
Your answer should be very brief. 2.33e+09. What is the difference between the Aid flow (current US$) in Lower middle income in 2009 and the Aid flow (current US$) in Croatia in 2010?
Provide a short and direct response. 3.84e+09. What is the difference between the Aid flow (current US$) of Lower middle income in 2009 and the Aid flow (current US$) of Yemen, Rep. in 2010?
Offer a terse response. 3.90e+09. What is the difference between the Aid flow (current US$) of Croatia in 2009 and the Aid flow (current US$) of Yemen, Rep. in 2010?
Offer a very short reply. 8.92e+07. What is the average Aid flow (current US$) in Europe(all income levels) per year?
Offer a very short reply. 2.43e+09. What is the average Aid flow (current US$) of Lower middle income per year?
Your answer should be very brief. 3.00e+09. What is the average Aid flow (current US$) in Croatia per year?
Ensure brevity in your answer.  9.27e+07. What is the average Aid flow (current US$) of Yemen, Rep. per year?
Your answer should be very brief. 2.49e+07. In the year 2003, what is the difference between the Aid flow (current US$) of Europe(all income levels) and Aid flow (current US$) of Lower middle income?
Offer a terse response. 2.22e+09. In the year 2003, what is the difference between the Aid flow (current US$) in Europe(all income levels) and Aid flow (current US$) in Croatia?
Your response must be concise. 3.98e+09. In the year 2003, what is the difference between the Aid flow (current US$) in Europe(all income levels) and Aid flow (current US$) in Yemen, Rep.?
Keep it short and to the point. 3.98e+09. In the year 2003, what is the difference between the Aid flow (current US$) in Lower middle income and Aid flow (current US$) in Croatia?
Provide a short and direct response. 1.75e+09. In the year 2003, what is the difference between the Aid flow (current US$) of Lower middle income and Aid flow (current US$) of Yemen, Rep.?
Provide a short and direct response. 1.76e+09. In the year 2003, what is the difference between the Aid flow (current US$) in Croatia and Aid flow (current US$) in Yemen, Rep.?
Give a very brief answer. 6.90e+05. In the year 2004, what is the difference between the Aid flow (current US$) in Europe(all income levels) and Aid flow (current US$) in Lower middle income?
Make the answer very short. 3.22e+09. In the year 2004, what is the difference between the Aid flow (current US$) in Europe(all income levels) and Aid flow (current US$) in Croatia?
Keep it short and to the point. 5.27e+09. In the year 2004, what is the difference between the Aid flow (current US$) of Europe(all income levels) and Aid flow (current US$) of Yemen, Rep.?
Make the answer very short. 5.27e+09. In the year 2004, what is the difference between the Aid flow (current US$) of Lower middle income and Aid flow (current US$) of Croatia?
Your response must be concise. 2.05e+09. In the year 2004, what is the difference between the Aid flow (current US$) of Lower middle income and Aid flow (current US$) of Yemen, Rep.?
Provide a short and direct response. 2.05e+09. In the year 2004, what is the difference between the Aid flow (current US$) of Croatia and Aid flow (current US$) of Yemen, Rep.?
Offer a terse response. 3.60e+05. In the year 2005, what is the difference between the Aid flow (current US$) in Europe(all income levels) and Aid flow (current US$) in Lower middle income?
Provide a short and direct response. -1.27e+09. In the year 2005, what is the difference between the Aid flow (current US$) in Europe(all income levels) and Aid flow (current US$) in Croatia?
Provide a short and direct response. 1.15e+09. In the year 2005, what is the difference between the Aid flow (current US$) of Europe(all income levels) and Aid flow (current US$) of Yemen, Rep.?
Keep it short and to the point. 1.17e+09. In the year 2005, what is the difference between the Aid flow (current US$) of Lower middle income and Aid flow (current US$) of Croatia?
Your response must be concise. 2.41e+09. In the year 2005, what is the difference between the Aid flow (current US$) of Lower middle income and Aid flow (current US$) of Yemen, Rep.?
Provide a short and direct response. 2.44e+09. In the year 2005, what is the difference between the Aid flow (current US$) of Croatia and Aid flow (current US$) of Yemen, Rep.?
Your answer should be compact. 2.44e+07. In the year 2006, what is the difference between the Aid flow (current US$) in Europe(all income levels) and Aid flow (current US$) in Lower middle income?
Your response must be concise. -1.52e+09. In the year 2006, what is the difference between the Aid flow (current US$) of Europe(all income levels) and Aid flow (current US$) of Croatia?
Offer a terse response. 1.34e+09. In the year 2006, what is the difference between the Aid flow (current US$) in Europe(all income levels) and Aid flow (current US$) in Yemen, Rep.?
Give a very brief answer. 1.44e+09. In the year 2006, what is the difference between the Aid flow (current US$) of Lower middle income and Aid flow (current US$) of Croatia?
Your answer should be very brief. 2.87e+09. In the year 2006, what is the difference between the Aid flow (current US$) of Lower middle income and Aid flow (current US$) of Yemen, Rep.?
Offer a terse response. 2.97e+09. In the year 2006, what is the difference between the Aid flow (current US$) of Croatia and Aid flow (current US$) of Yemen, Rep.?
Offer a very short reply. 9.90e+07. In the year 2007, what is the difference between the Aid flow (current US$) of Europe(all income levels) and Aid flow (current US$) of Lower middle income?
Offer a very short reply. -1.77e+09. In the year 2007, what is the difference between the Aid flow (current US$) in Europe(all income levels) and Aid flow (current US$) in Croatia?
Your answer should be very brief. 1.35e+09. In the year 2007, what is the difference between the Aid flow (current US$) in Europe(all income levels) and Aid flow (current US$) in Yemen, Rep.?
Give a very brief answer. 1.44e+09. In the year 2007, what is the difference between the Aid flow (current US$) in Lower middle income and Aid flow (current US$) in Croatia?
Offer a very short reply. 3.12e+09. In the year 2007, what is the difference between the Aid flow (current US$) of Lower middle income and Aid flow (current US$) of Yemen, Rep.?
Your response must be concise. 3.20e+09. In the year 2007, what is the difference between the Aid flow (current US$) of Croatia and Aid flow (current US$) of Yemen, Rep.?
Offer a terse response. 8.31e+07. In the year 2008, what is the difference between the Aid flow (current US$) in Europe(all income levels) and Aid flow (current US$) in Lower middle income?
Ensure brevity in your answer.  -2.06e+09. In the year 2008, what is the difference between the Aid flow (current US$) of Europe(all income levels) and Aid flow (current US$) of Croatia?
Give a very brief answer. 1.59e+09. In the year 2008, what is the difference between the Aid flow (current US$) of Europe(all income levels) and Aid flow (current US$) of Yemen, Rep.?
Provide a succinct answer. 1.76e+09. In the year 2008, what is the difference between the Aid flow (current US$) in Lower middle income and Aid flow (current US$) in Croatia?
Your answer should be very brief. 3.65e+09. In the year 2008, what is the difference between the Aid flow (current US$) in Lower middle income and Aid flow (current US$) in Yemen, Rep.?
Your response must be concise. 3.81e+09. In the year 2008, what is the difference between the Aid flow (current US$) of Croatia and Aid flow (current US$) of Yemen, Rep.?
Provide a short and direct response. 1.63e+08. In the year 2009, what is the difference between the Aid flow (current US$) of Europe(all income levels) and Aid flow (current US$) of Lower middle income?
Offer a terse response. -1.57e+09. In the year 2009, what is the difference between the Aid flow (current US$) of Europe(all income levels) and Aid flow (current US$) of Croatia?
Make the answer very short. 2.24e+09. In the year 2009, what is the difference between the Aid flow (current US$) of Europe(all income levels) and Aid flow (current US$) of Yemen, Rep.?
Offer a terse response. 2.35e+09. In the year 2009, what is the difference between the Aid flow (current US$) of Lower middle income and Aid flow (current US$) of Croatia?
Provide a short and direct response. 3.81e+09. In the year 2009, what is the difference between the Aid flow (current US$) in Lower middle income and Aid flow (current US$) in Yemen, Rep.?
Make the answer very short. 3.92e+09. In the year 2009, what is the difference between the Aid flow (current US$) of Croatia and Aid flow (current US$) of Yemen, Rep.?
Provide a short and direct response. 1.06e+08. In the year 2010, what is the difference between the Aid flow (current US$) of Europe(all income levels) and Aid flow (current US$) of Lower middle income?
Give a very brief answer. -1.84e+09. In the year 2010, what is the difference between the Aid flow (current US$) in Europe(all income levels) and Aid flow (current US$) in Croatia?
Make the answer very short. 1.75e+09. In the year 2010, what is the difference between the Aid flow (current US$) in Europe(all income levels) and Aid flow (current US$) in Yemen, Rep.?
Your answer should be very brief. 1.82e+09. In the year 2010, what is the difference between the Aid flow (current US$) of Lower middle income and Aid flow (current US$) of Croatia?
Offer a very short reply. 3.59e+09. In the year 2010, what is the difference between the Aid flow (current US$) of Lower middle income and Aid flow (current US$) of Yemen, Rep.?
Your answer should be very brief. 3.66e+09. In the year 2010, what is the difference between the Aid flow (current US$) of Croatia and Aid flow (current US$) of Yemen, Rep.?
Your answer should be compact. 6.47e+07. What is the ratio of the Aid flow (current US$) in Europe(all income levels) in 2003 to that in 2004?
Keep it short and to the point. 0.76. What is the ratio of the Aid flow (current US$) of Lower middle income in 2003 to that in 2004?
Provide a short and direct response. 0.86. What is the ratio of the Aid flow (current US$) of Croatia in 2003 to that in 2004?
Provide a short and direct response. 1.12. What is the ratio of the Aid flow (current US$) of Yemen, Rep. in 2003 to that in 2004?
Keep it short and to the point. 1.1. What is the ratio of the Aid flow (current US$) of Europe(all income levels) in 2003 to that in 2005?
Your answer should be very brief. 3.35. What is the ratio of the Aid flow (current US$) in Lower middle income in 2003 to that in 2005?
Provide a short and direct response. 0.72. What is the ratio of the Aid flow (current US$) of Croatia in 2003 to that in 2005?
Make the answer very short. 0.52. What is the ratio of the Aid flow (current US$) in Yemen, Rep. in 2003 to that in 2005?
Provide a succinct answer. 0.97. What is the ratio of the Aid flow (current US$) in Europe(all income levels) in 2003 to that in 2006?
Ensure brevity in your answer.  2.73. What is the ratio of the Aid flow (current US$) in Lower middle income in 2003 to that in 2006?
Offer a terse response. 0.6. What is the ratio of the Aid flow (current US$) of Croatia in 2003 to that in 2006?
Your answer should be compact. 0.22. What is the ratio of the Aid flow (current US$) in Yemen, Rep. in 2003 to that in 2006?
Offer a very short reply. 1.15. What is the ratio of the Aid flow (current US$) of Europe(all income levels) in 2003 to that in 2007?
Offer a very short reply. 2.75. What is the ratio of the Aid flow (current US$) of Lower middle income in 2003 to that in 2007?
Your answer should be compact. 0.55. What is the ratio of the Aid flow (current US$) in Croatia in 2003 to that in 2007?
Make the answer very short. 0.27. What is the ratio of the Aid flow (current US$) of Yemen, Rep. in 2003 to that in 2007?
Your answer should be very brief. 1.48. What is the ratio of the Aid flow (current US$) of Europe(all income levels) in 2003 to that in 2008?
Your answer should be compact. 2.26. What is the ratio of the Aid flow (current US$) of Lower middle income in 2003 to that in 2008?
Offer a very short reply. 0.47. What is the ratio of the Aid flow (current US$) of Croatia in 2003 to that in 2008?
Offer a terse response. 0.15. What is the ratio of the Aid flow (current US$) of Yemen, Rep. in 2003 to that in 2008?
Ensure brevity in your answer.  1.48. What is the ratio of the Aid flow (current US$) of Europe(all income levels) in 2003 to that in 2009?
Ensure brevity in your answer.  1.69. What is the ratio of the Aid flow (current US$) of Lower middle income in 2003 to that in 2009?
Provide a short and direct response. 0.45. What is the ratio of the Aid flow (current US$) of Croatia in 2003 to that in 2009?
Your answer should be very brief. 0.21. What is the ratio of the Aid flow (current US$) of Yemen, Rep. in 2003 to that in 2009?
Offer a terse response. 1.11. What is the ratio of the Aid flow (current US$) in Europe(all income levels) in 2003 to that in 2010?
Make the answer very short. 2.15. What is the ratio of the Aid flow (current US$) of Lower middle income in 2003 to that in 2010?
Offer a very short reply. 0.48. What is the ratio of the Aid flow (current US$) of Croatia in 2003 to that in 2010?
Keep it short and to the point. 0.26. What is the ratio of the Aid flow (current US$) of Yemen, Rep. in 2003 to that in 2010?
Ensure brevity in your answer.  0.64. What is the ratio of the Aid flow (current US$) in Europe(all income levels) in 2004 to that in 2005?
Give a very brief answer. 4.43. What is the ratio of the Aid flow (current US$) of Lower middle income in 2004 to that in 2005?
Offer a terse response. 0.84. What is the ratio of the Aid flow (current US$) in Croatia in 2004 to that in 2005?
Your answer should be compact. 0.47. What is the ratio of the Aid flow (current US$) of Yemen, Rep. in 2004 to that in 2005?
Give a very brief answer. 0.88. What is the ratio of the Aid flow (current US$) in Europe(all income levels) in 2004 to that in 2006?
Keep it short and to the point. 3.61. What is the ratio of the Aid flow (current US$) of Lower middle income in 2004 to that in 2006?
Provide a short and direct response. 0.69. What is the ratio of the Aid flow (current US$) of Croatia in 2004 to that in 2006?
Provide a short and direct response. 0.2. What is the ratio of the Aid flow (current US$) in Yemen, Rep. in 2004 to that in 2006?
Offer a very short reply. 1.05. What is the ratio of the Aid flow (current US$) of Europe(all income levels) in 2004 to that in 2007?
Offer a very short reply. 3.64. What is the ratio of the Aid flow (current US$) of Lower middle income in 2004 to that in 2007?
Offer a terse response. 0.64. What is the ratio of the Aid flow (current US$) of Croatia in 2004 to that in 2007?
Keep it short and to the point. 0.24. What is the ratio of the Aid flow (current US$) in Yemen, Rep. in 2004 to that in 2007?
Keep it short and to the point. 1.34. What is the ratio of the Aid flow (current US$) in Europe(all income levels) in 2004 to that in 2008?
Give a very brief answer. 2.99. What is the ratio of the Aid flow (current US$) in Lower middle income in 2004 to that in 2008?
Ensure brevity in your answer.  0.54. What is the ratio of the Aid flow (current US$) of Croatia in 2004 to that in 2008?
Give a very brief answer. 0.13. What is the ratio of the Aid flow (current US$) in Yemen, Rep. in 2004 to that in 2008?
Offer a very short reply. 1.34. What is the ratio of the Aid flow (current US$) in Europe(all income levels) in 2004 to that in 2009?
Give a very brief answer. 2.23. What is the ratio of the Aid flow (current US$) in Lower middle income in 2004 to that in 2009?
Ensure brevity in your answer.  0.53. What is the ratio of the Aid flow (current US$) in Croatia in 2004 to that in 2009?
Provide a succinct answer. 0.19. What is the ratio of the Aid flow (current US$) of Yemen, Rep. in 2004 to that in 2009?
Provide a short and direct response. 1.01. What is the ratio of the Aid flow (current US$) in Europe(all income levels) in 2004 to that in 2010?
Give a very brief answer. 2.85. What is the ratio of the Aid flow (current US$) of Lower middle income in 2004 to that in 2010?
Provide a short and direct response. 0.56. What is the ratio of the Aid flow (current US$) of Croatia in 2004 to that in 2010?
Offer a very short reply. 0.23. What is the ratio of the Aid flow (current US$) in Yemen, Rep. in 2004 to that in 2010?
Provide a short and direct response. 0.58. What is the ratio of the Aid flow (current US$) of Europe(all income levels) in 2005 to that in 2006?
Your response must be concise. 0.82. What is the ratio of the Aid flow (current US$) in Lower middle income in 2005 to that in 2006?
Your response must be concise. 0.82. What is the ratio of the Aid flow (current US$) of Croatia in 2005 to that in 2006?
Offer a terse response. 0.42. What is the ratio of the Aid flow (current US$) in Yemen, Rep. in 2005 to that in 2006?
Your response must be concise. 1.19. What is the ratio of the Aid flow (current US$) in Europe(all income levels) in 2005 to that in 2007?
Provide a short and direct response. 0.82. What is the ratio of the Aid flow (current US$) in Lower middle income in 2005 to that in 2007?
Your answer should be compact. 0.77. What is the ratio of the Aid flow (current US$) in Croatia in 2005 to that in 2007?
Keep it short and to the point. 0.51. What is the ratio of the Aid flow (current US$) in Yemen, Rep. in 2005 to that in 2007?
Your answer should be compact. 1.52. What is the ratio of the Aid flow (current US$) of Europe(all income levels) in 2005 to that in 2008?
Provide a short and direct response. 0.67. What is the ratio of the Aid flow (current US$) in Lower middle income in 2005 to that in 2008?
Your answer should be compact. 0.64. What is the ratio of the Aid flow (current US$) of Croatia in 2005 to that in 2008?
Provide a succinct answer. 0.28. What is the ratio of the Aid flow (current US$) of Yemen, Rep. in 2005 to that in 2008?
Your response must be concise. 1.53. What is the ratio of the Aid flow (current US$) in Europe(all income levels) in 2005 to that in 2009?
Offer a terse response. 0.5. What is the ratio of the Aid flow (current US$) in Lower middle income in 2005 to that in 2009?
Provide a succinct answer. 0.62. What is the ratio of the Aid flow (current US$) in Croatia in 2005 to that in 2009?
Your answer should be compact. 0.4. What is the ratio of the Aid flow (current US$) of Yemen, Rep. in 2005 to that in 2009?
Provide a short and direct response. 1.15. What is the ratio of the Aid flow (current US$) of Europe(all income levels) in 2005 to that in 2010?
Make the answer very short. 0.64. What is the ratio of the Aid flow (current US$) of Lower middle income in 2005 to that in 2010?
Ensure brevity in your answer.  0.67. What is the ratio of the Aid flow (current US$) of Croatia in 2005 to that in 2010?
Ensure brevity in your answer.  0.49. What is the ratio of the Aid flow (current US$) in Yemen, Rep. in 2005 to that in 2010?
Give a very brief answer. 0.66. What is the ratio of the Aid flow (current US$) in Europe(all income levels) in 2006 to that in 2007?
Your answer should be very brief. 1.01. What is the ratio of the Aid flow (current US$) in Lower middle income in 2006 to that in 2007?
Ensure brevity in your answer.  0.93. What is the ratio of the Aid flow (current US$) in Croatia in 2006 to that in 2007?
Provide a short and direct response. 1.21. What is the ratio of the Aid flow (current US$) of Yemen, Rep. in 2006 to that in 2007?
Provide a short and direct response. 1.28. What is the ratio of the Aid flow (current US$) of Europe(all income levels) in 2006 to that in 2008?
Your response must be concise. 0.83. What is the ratio of the Aid flow (current US$) in Lower middle income in 2006 to that in 2008?
Keep it short and to the point. 0.78. What is the ratio of the Aid flow (current US$) of Croatia in 2006 to that in 2008?
Give a very brief answer. 0.67. What is the ratio of the Aid flow (current US$) in Yemen, Rep. in 2006 to that in 2008?
Provide a succinct answer. 1.28. What is the ratio of the Aid flow (current US$) of Europe(all income levels) in 2006 to that in 2009?
Keep it short and to the point. 0.62. What is the ratio of the Aid flow (current US$) in Lower middle income in 2006 to that in 2009?
Your answer should be compact. 0.76. What is the ratio of the Aid flow (current US$) in Croatia in 2006 to that in 2009?
Make the answer very short. 0.94. What is the ratio of the Aid flow (current US$) in Yemen, Rep. in 2006 to that in 2009?
Offer a terse response. 0.96. What is the ratio of the Aid flow (current US$) in Europe(all income levels) in 2006 to that in 2010?
Give a very brief answer. 0.79. What is the ratio of the Aid flow (current US$) in Lower middle income in 2006 to that in 2010?
Your response must be concise. 0.81. What is the ratio of the Aid flow (current US$) in Croatia in 2006 to that in 2010?
Make the answer very short. 1.15. What is the ratio of the Aid flow (current US$) of Yemen, Rep. in 2006 to that in 2010?
Your answer should be very brief. 0.56. What is the ratio of the Aid flow (current US$) of Europe(all income levels) in 2007 to that in 2008?
Your answer should be very brief. 0.82. What is the ratio of the Aid flow (current US$) of Lower middle income in 2007 to that in 2008?
Ensure brevity in your answer.  0.84. What is the ratio of the Aid flow (current US$) in Croatia in 2007 to that in 2008?
Give a very brief answer. 0.56. What is the ratio of the Aid flow (current US$) in Europe(all income levels) in 2007 to that in 2009?
Offer a very short reply. 0.61. What is the ratio of the Aid flow (current US$) in Lower middle income in 2007 to that in 2009?
Give a very brief answer. 0.82. What is the ratio of the Aid flow (current US$) of Croatia in 2007 to that in 2009?
Your answer should be very brief. 0.78. What is the ratio of the Aid flow (current US$) in Yemen, Rep. in 2007 to that in 2009?
Make the answer very short. 0.75. What is the ratio of the Aid flow (current US$) in Europe(all income levels) in 2007 to that in 2010?
Provide a succinct answer. 0.78. What is the ratio of the Aid flow (current US$) in Lower middle income in 2007 to that in 2010?
Provide a short and direct response. 0.87. What is the ratio of the Aid flow (current US$) in Croatia in 2007 to that in 2010?
Keep it short and to the point. 0.96. What is the ratio of the Aid flow (current US$) of Yemen, Rep. in 2007 to that in 2010?
Make the answer very short. 0.44. What is the ratio of the Aid flow (current US$) of Europe(all income levels) in 2008 to that in 2009?
Give a very brief answer. 0.75. What is the ratio of the Aid flow (current US$) of Lower middle income in 2008 to that in 2009?
Your response must be concise. 0.97. What is the ratio of the Aid flow (current US$) of Croatia in 2008 to that in 2009?
Provide a short and direct response. 1.39. What is the ratio of the Aid flow (current US$) in Yemen, Rep. in 2008 to that in 2009?
Provide a succinct answer. 0.75. What is the ratio of the Aid flow (current US$) of Europe(all income levels) in 2008 to that in 2010?
Give a very brief answer. 0.95. What is the ratio of the Aid flow (current US$) in Lower middle income in 2008 to that in 2010?
Provide a short and direct response. 1.04. What is the ratio of the Aid flow (current US$) of Croatia in 2008 to that in 2010?
Make the answer very short. 1.72. What is the ratio of the Aid flow (current US$) in Yemen, Rep. in 2008 to that in 2010?
Offer a terse response. 0.43. What is the ratio of the Aid flow (current US$) in Europe(all income levels) in 2009 to that in 2010?
Provide a succinct answer. 1.27. What is the ratio of the Aid flow (current US$) in Lower middle income in 2009 to that in 2010?
Your response must be concise. 1.07. What is the ratio of the Aid flow (current US$) of Croatia in 2009 to that in 2010?
Give a very brief answer. 1.23. What is the ratio of the Aid flow (current US$) in Yemen, Rep. in 2009 to that in 2010?
Give a very brief answer. 0.58. What is the difference between the highest and the second highest Aid flow (current US$) in Europe(all income levels)?
Provide a short and direct response. 1.29e+09. What is the difference between the highest and the second highest Aid flow (current US$) of Lower middle income?
Give a very brief answer. 1.15e+08. What is the difference between the highest and the second highest Aid flow (current US$) in Croatia?
Provide a succinct answer. 5.12e+07. What is the difference between the highest and the second highest Aid flow (current US$) of Yemen, Rep.?
Your response must be concise. 1.37e+07. What is the difference between the highest and the lowest Aid flow (current US$) in Europe(all income levels)?
Your answer should be very brief. 4.10e+09. What is the difference between the highest and the lowest Aid flow (current US$) in Lower middle income?
Provide a short and direct response. 2.16e+09. What is the difference between the highest and the lowest Aid flow (current US$) of Croatia?
Make the answer very short. 1.57e+08. What is the difference between the highest and the lowest Aid flow (current US$) in Yemen, Rep.?
Your answer should be very brief. 2.30e+07. 